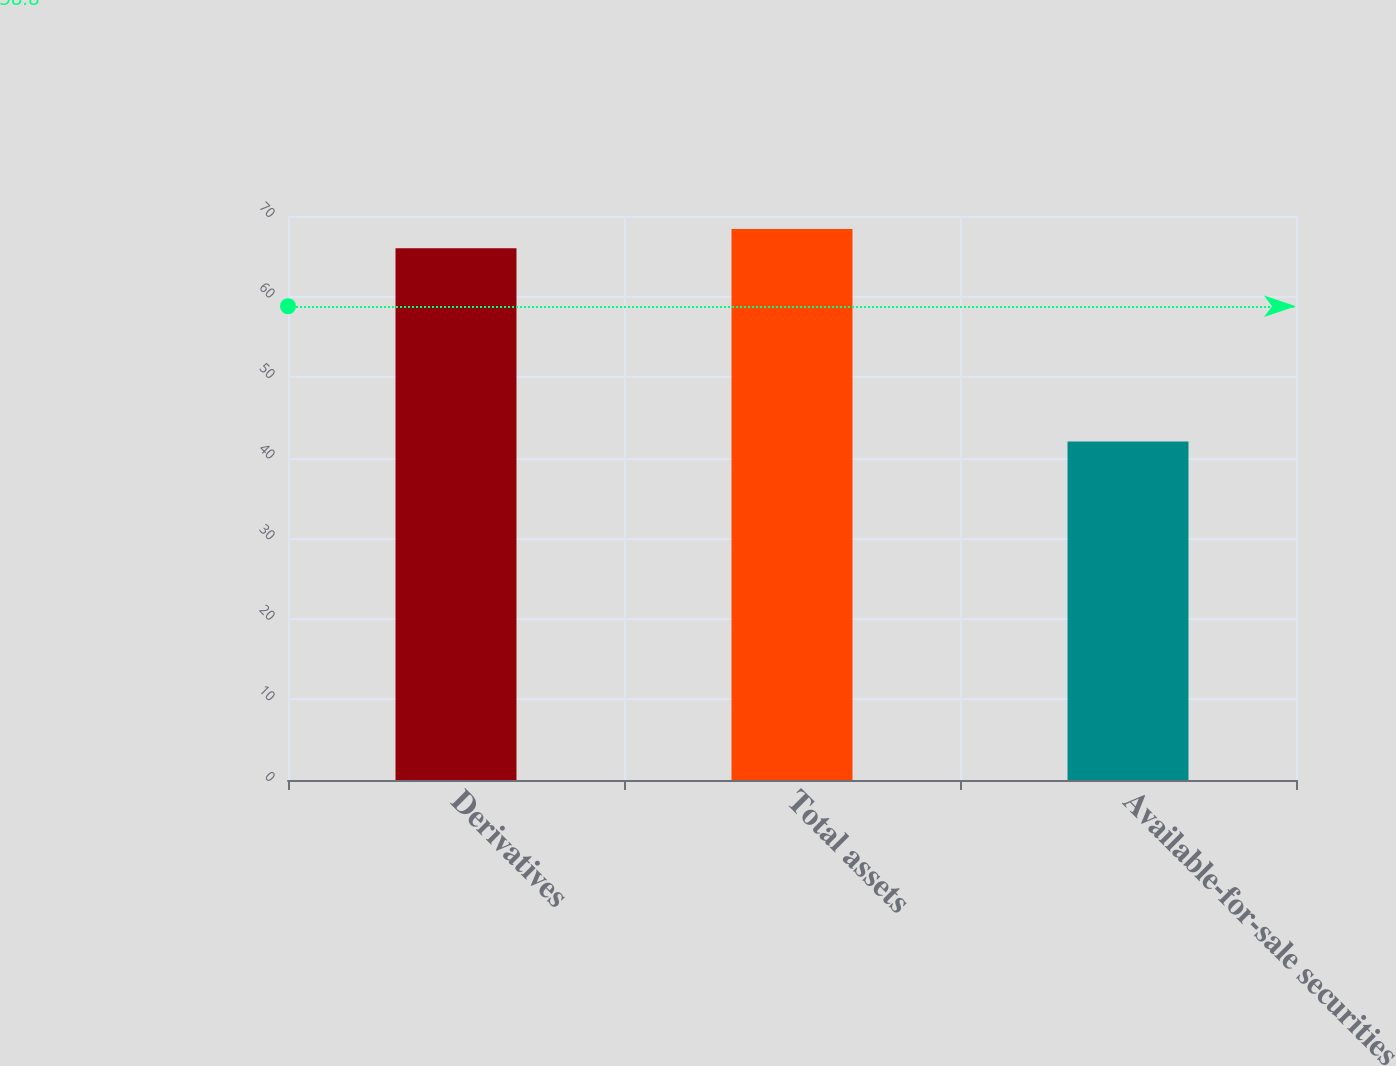Convert chart to OTSL. <chart><loc_0><loc_0><loc_500><loc_500><bar_chart><fcel>Derivatives<fcel>Total assets<fcel>Available-for-sale securities<nl><fcel>66<fcel>68.4<fcel>42<nl></chart> 